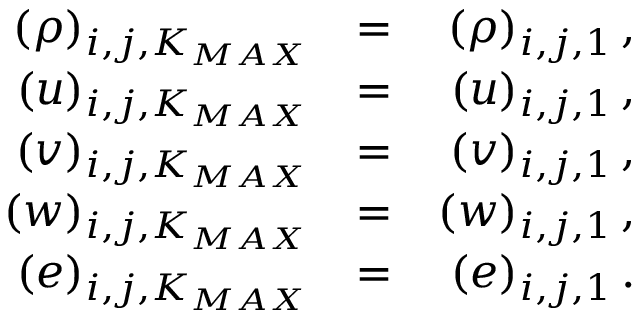Convert formula to latex. <formula><loc_0><loc_0><loc_500><loc_500>\begin{array} { r l r } { ( \rho ) _ { i , j , K _ { M A X } } } & { = } & { ( \rho ) _ { i , j , 1 } \, , } \\ { ( u ) _ { i , j , K _ { M A X } } } & { = } & { ( u ) _ { i , j , 1 } \, , } \\ { ( v ) _ { i , j , K _ { M A X } } } & { = } & { ( v ) _ { i , j , 1 } \, , } \\ { ( w ) _ { i , j , K _ { M A X } } } & { = } & { ( w ) _ { i , j , 1 } \, , } \\ { ( e ) _ { i , j , K _ { M A X } } } & { = } & { ( e ) _ { i , j , 1 } \, . } \end{array}</formula> 